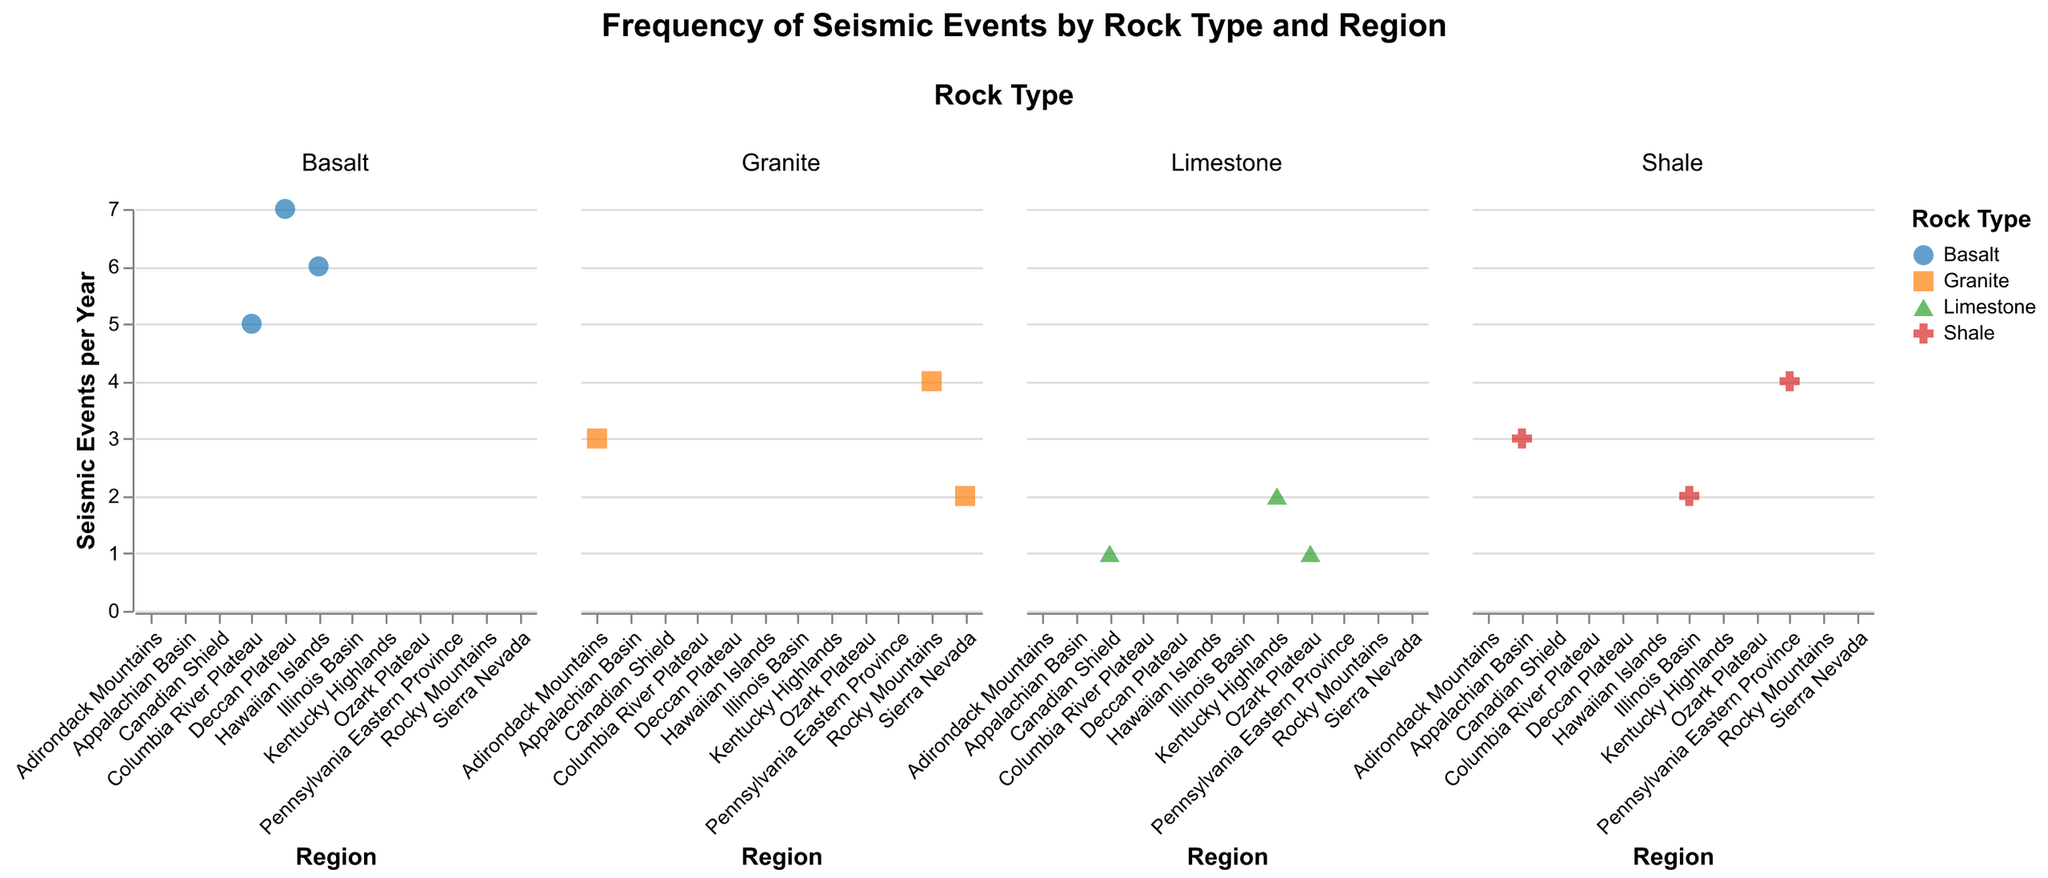What's the title of the plot? The title of the plot is positioned at the top center of the chart, clear and legible, specifying what the plot represents.
Answer: Frequency of Seismic Events by Rock Type and Region How many regions have Limestone rock type? By counting the plots under the "Limestone" column, we observe that there are three regions.
Answer: 3 Which rock type shows the highest frequency of seismic events? Looking at the y-axis values across different rock types, the highest frequency (7) is observed for Basalt in the Deccan Plateau region.
Answer: Basalt Which region with Granite rock type has the highest seismic event frequency? By focusing on the Granite column and comparing the y-axis ticks, Rocky Mountains has the highest frequency with a value of 4.
Answer: Rocky Mountains What's the average frequency of seismic events for the Shale rock type? The Shale column has data points with frequencies of 3, 2, and 4. Averaging these values: (3 + 2 + 4) / 3 = 3.
Answer: 3 How do the seismic frequencies generally compare between Granite and Basalt? Basalt generally shows higher frequencies, with values ranging from 5 to 7, whereas Granite ranges from 2 to 4.
Answer: Basalt is generally higher Which Limestone region has more seismic events than Canadian Shield? Both the Kentucky Highlands (2 events) and Ozark Plateau (1 event) are compared to Canadian Shield (1 event). Kentucky Highlands has more.
Answer: Kentucky Highlands Is there any rock type that has regions with significantly different seismic frequencies? Observing the scatter plots, Basalt shows a wide range of frequencies from 5 (Columbia River Plateau) to 7 (Deccan Plateau), indicating significant variation.
Answer: Basalt 